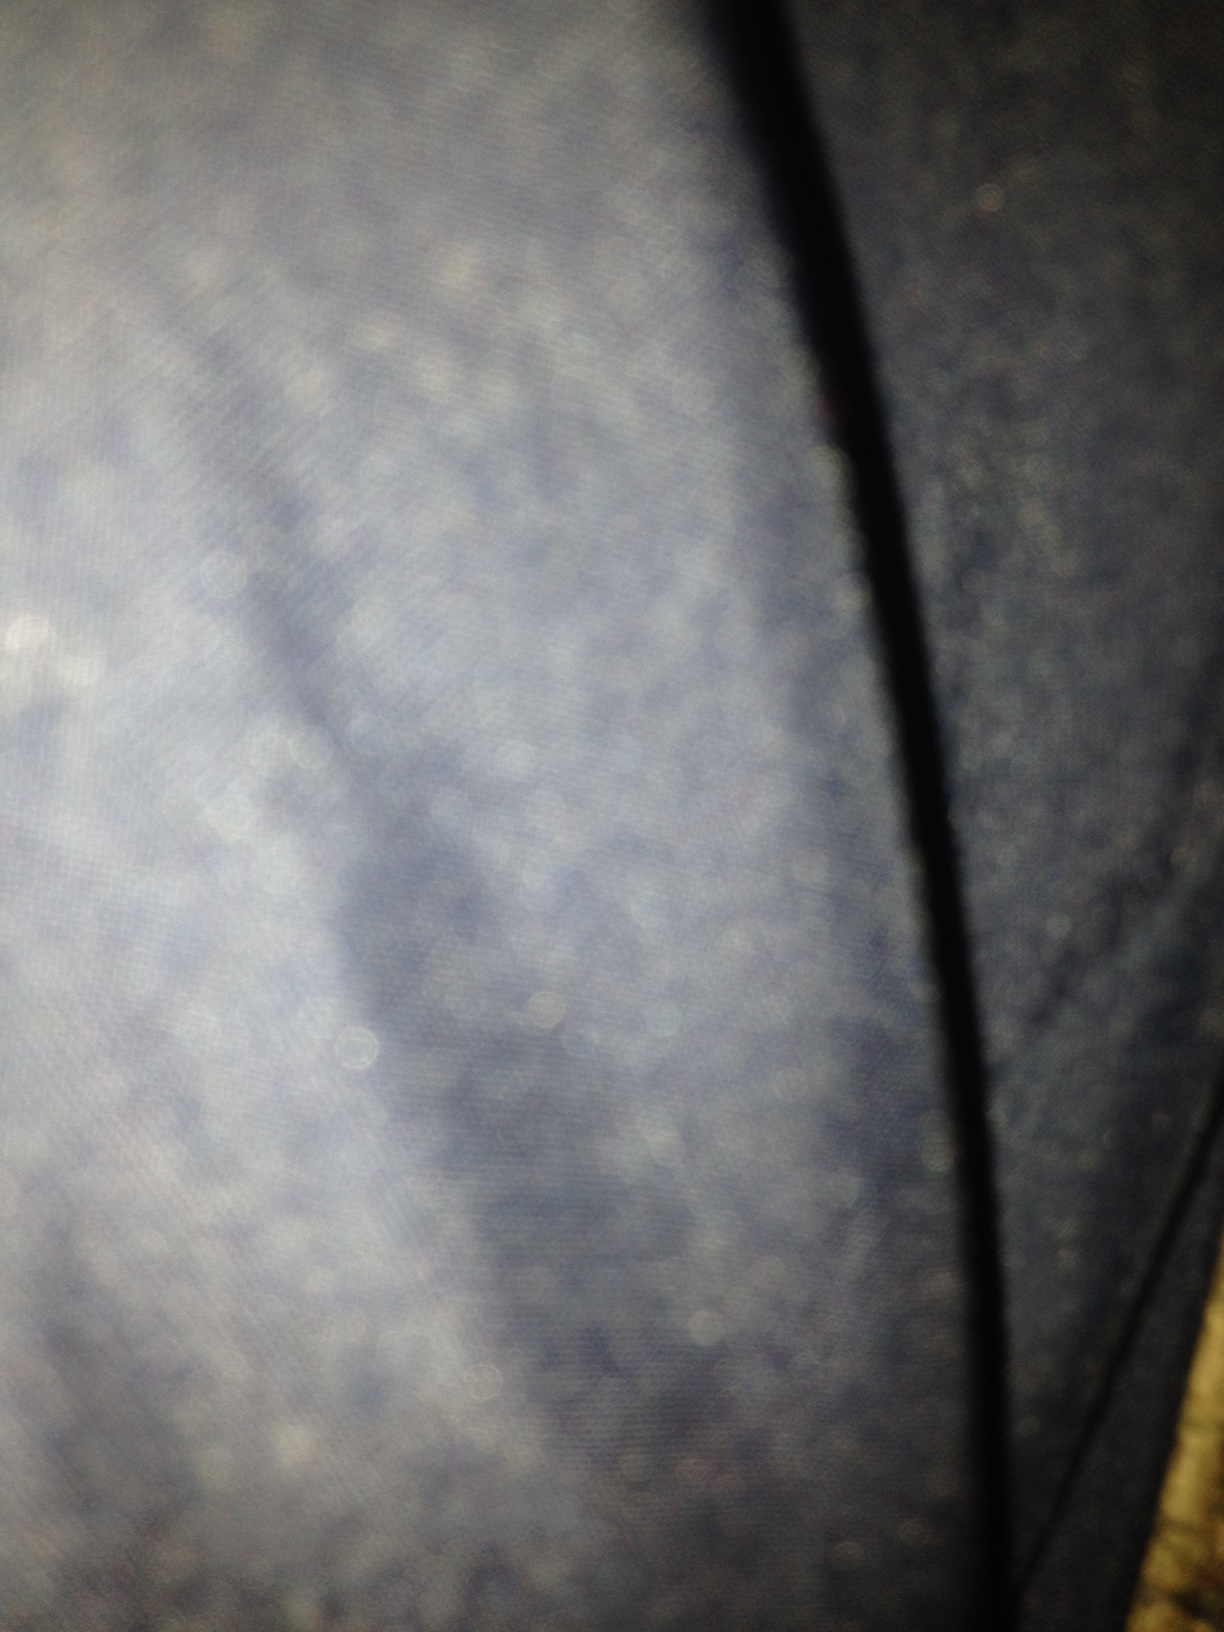What did I take a picture of? The picture is too blurred to clearly identify specific objects, but it seems to capture a close-up view of a textured fabric, possibly a piece of clothing like denim jeans. The lack of focus and excessive closeness make it impossible to distinguish specific details. 